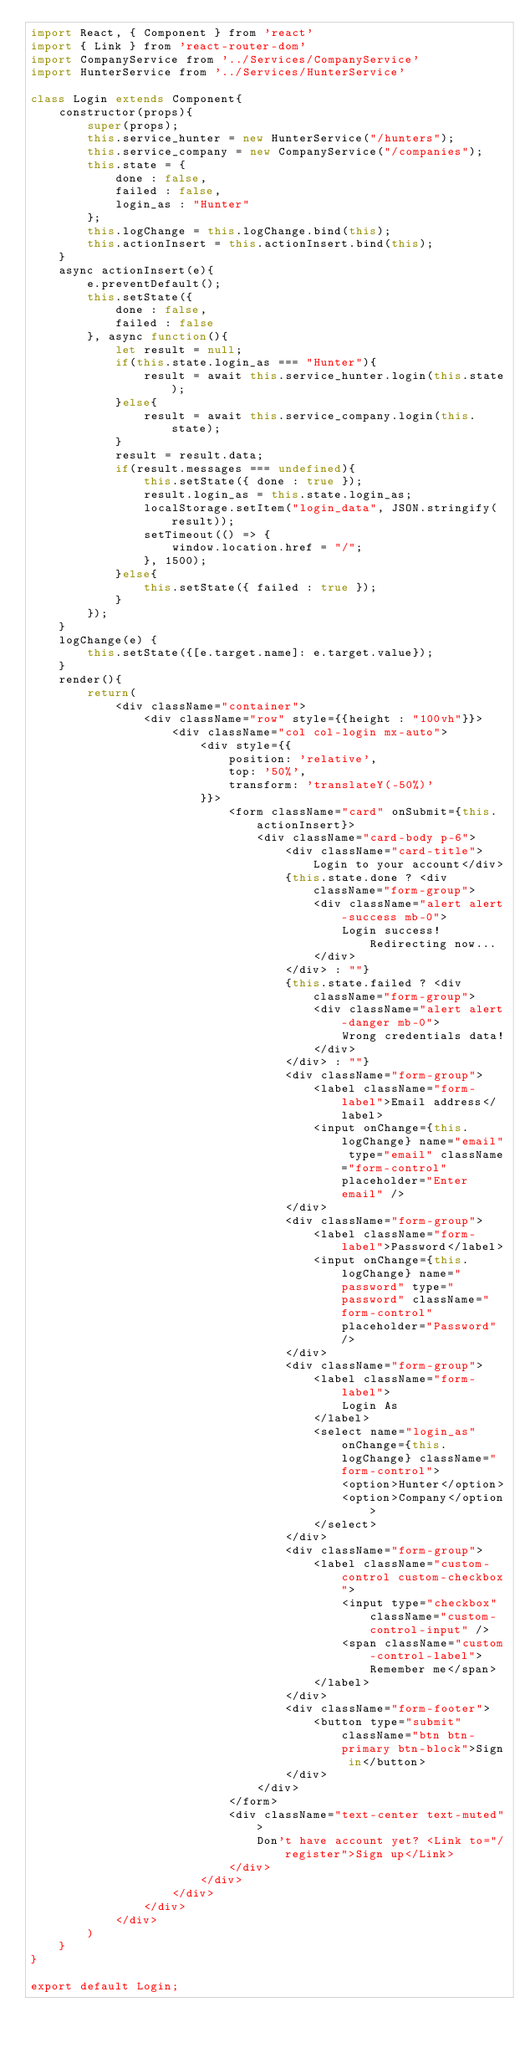Convert code to text. <code><loc_0><loc_0><loc_500><loc_500><_JavaScript_>import React, { Component } from 'react'
import { Link } from 'react-router-dom'
import CompanyService from '../Services/CompanyService'
import HunterService from '../Services/HunterService'

class Login extends Component{
    constructor(props){
        super(props);
        this.service_hunter = new HunterService("/hunters");
        this.service_company = new CompanyService("/companies");
        this.state = {
            done : false,
            failed : false,
            login_as : "Hunter"
        };
        this.logChange = this.logChange.bind(this);
        this.actionInsert = this.actionInsert.bind(this);
    }
    async actionInsert(e){
        e.preventDefault();
        this.setState({
            done : false,
            failed : false
        }, async function(){
            let result = null;
            if(this.state.login_as === "Hunter"){
                result = await this.service_hunter.login(this.state);
            }else{
                result = await this.service_company.login(this.state);
            }
            result = result.data;
            if(result.messages === undefined){
                this.setState({ done : true });
                result.login_as = this.state.login_as;
                localStorage.setItem("login_data", JSON.stringify(result));
                setTimeout(() => {
                    window.location.href = "/";
                }, 1500);
            }else{
                this.setState({ failed : true });
            }
        });
    }
    logChange(e) {
        this.setState({[e.target.name]: e.target.value});  
    }
    render(){
        return(
            <div className="container">
                <div className="row" style={{height : "100vh"}}>
                    <div className="col col-login mx-auto">
                        <div style={{
                            position: 'relative',
                            top: '50%',
                            transform: 'translateY(-50%)'
                        }}>
                            <form className="card" onSubmit={this.actionInsert}>
                                <div className="card-body p-6">
                                    <div className="card-title">Login to your account</div>
                                    {this.state.done ? <div className="form-group">
                                        <div className="alert alert-success mb-0">
                                            Login success! Redirecting now...
                                        </div>
                                    </div> : ""}
                                    {this.state.failed ? <div className="form-group">
                                        <div className="alert alert-danger mb-0">
                                            Wrong credentials data!
                                        </div>
                                    </div> : ""}
                                    <div className="form-group">
                                        <label className="form-label">Email address</label>
                                        <input onChange={this.logChange} name="email" type="email" className="form-control" placeholder="Enter email" />
                                    </div>
                                    <div className="form-group">
                                        <label className="form-label">Password</label>
                                        <input onChange={this.logChange} name="password" type="password" className="form-control" placeholder="Password" />
                                    </div>
                                    <div className="form-group">
                                        <label className="form-label">
                                            Login As
                                        </label>
                                        <select name="login_as" onChange={this.logChange} className="form-control">
                                            <option>Hunter</option>
                                            <option>Company</option>
                                        </select>
                                    </div>
                                    <div className="form-group">
                                        <label className="custom-control custom-checkbox">
                                            <input type="checkbox" className="custom-control-input" />
                                            <span className="custom-control-label">Remember me</span>
                                        </label>
                                    </div>
                                    <div className="form-footer">
                                        <button type="submit" className="btn btn-primary btn-block">Sign in</button>
                                    </div>
                                </div>
                            </form>
                            <div className="text-center text-muted">
                                Don't have account yet? <Link to="/register">Sign up</Link>
                            </div>
                        </div>
                    </div>
                </div>
            </div>
        )
    }
}

export default Login;</code> 